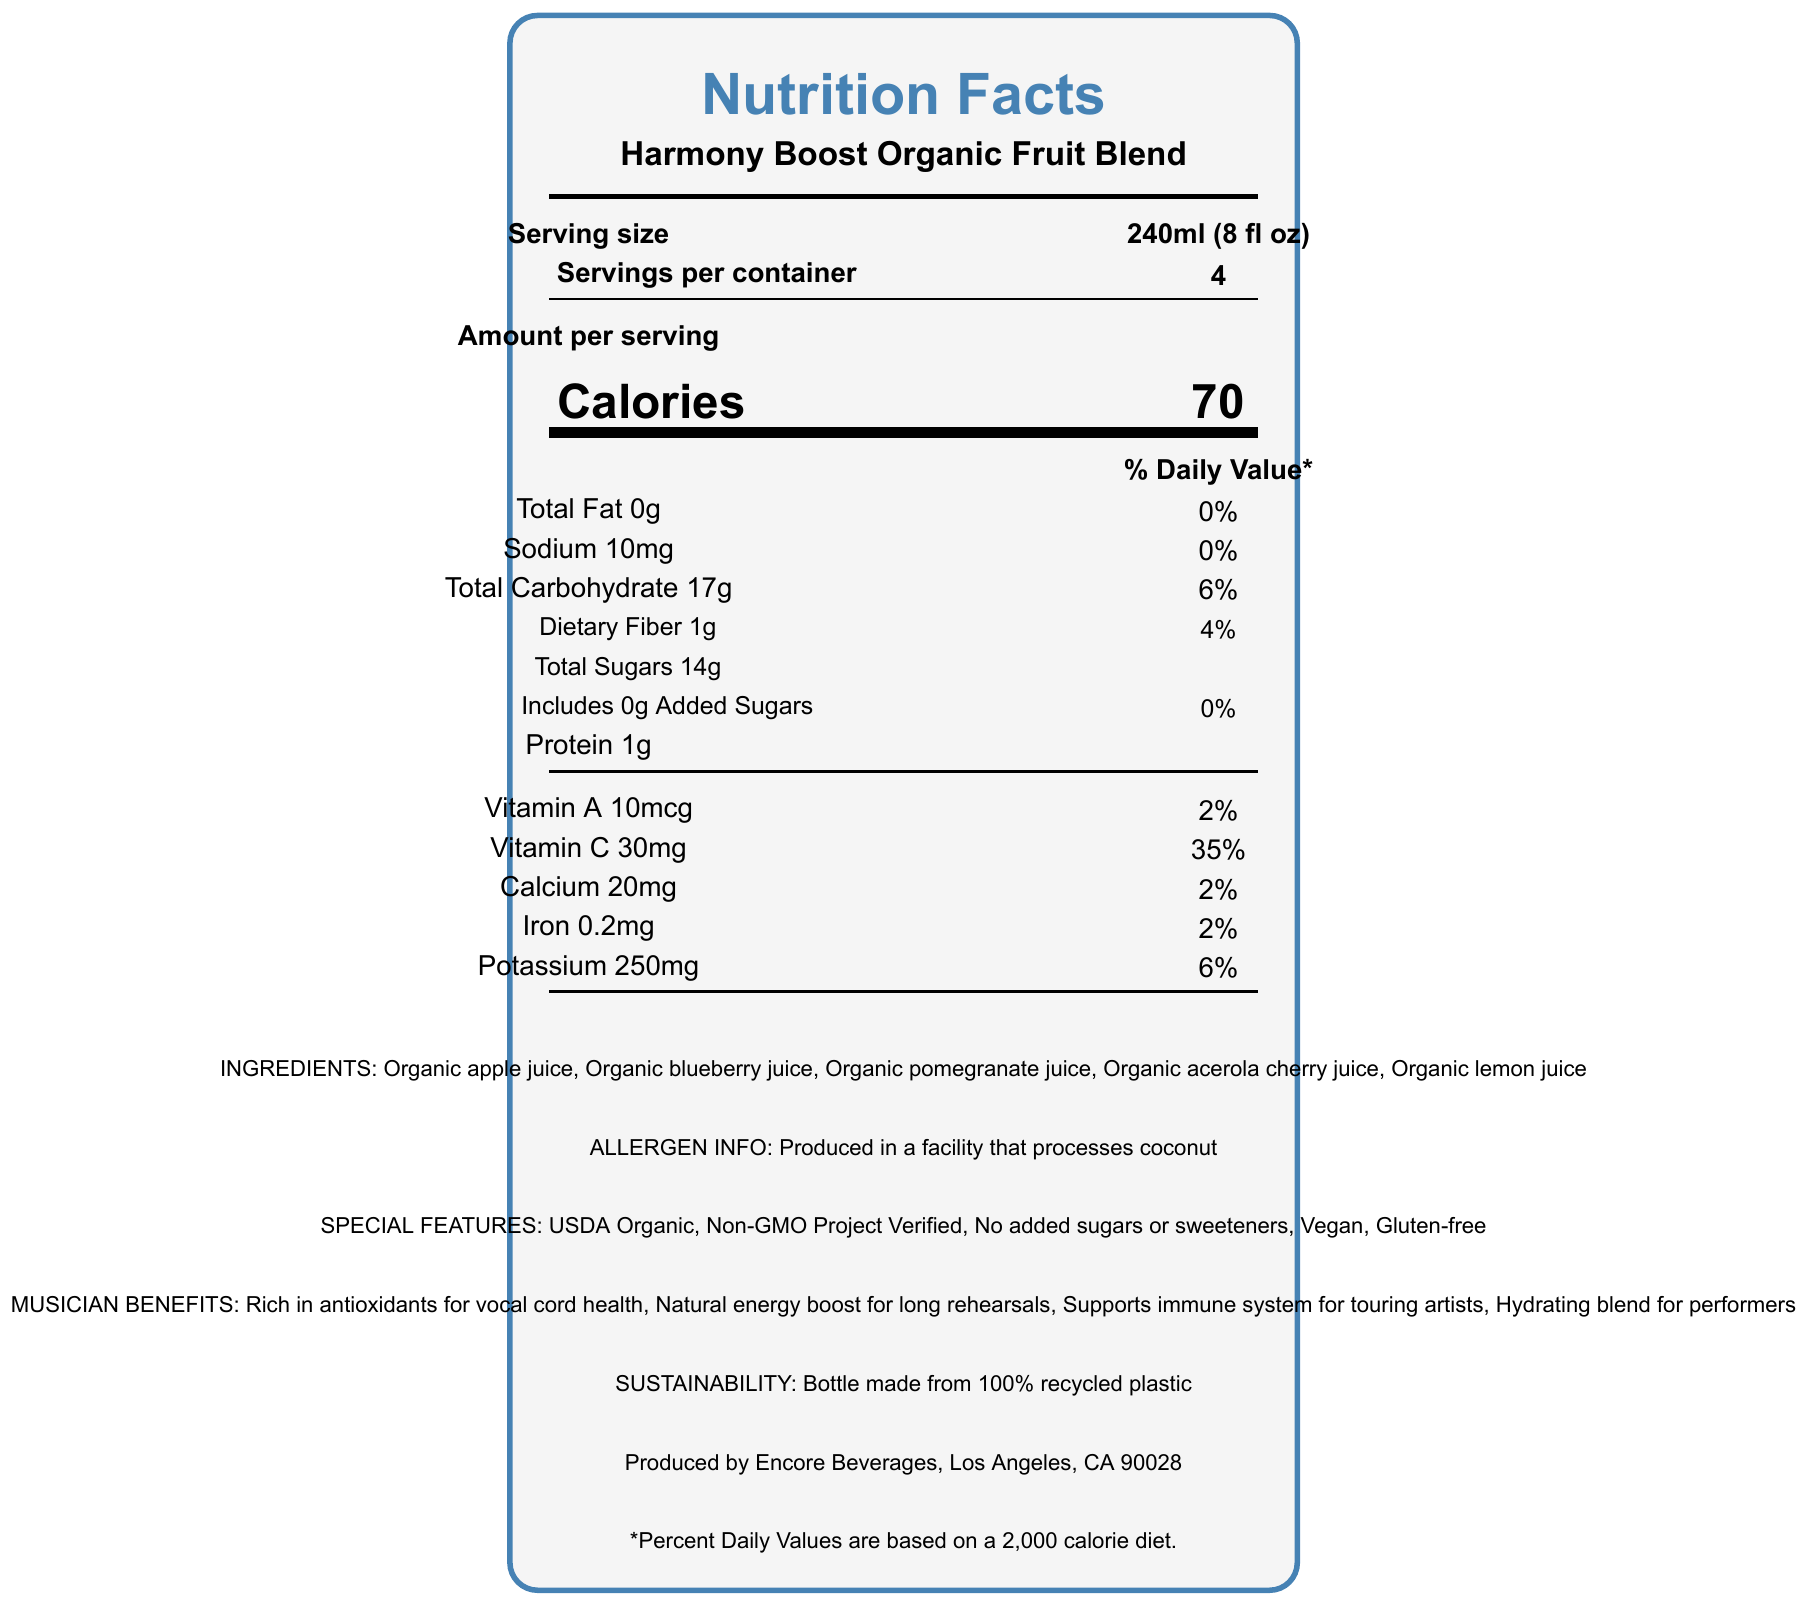what is the serving size of Harmony Boost Organic Fruit Blend? The document specifies the serving size as 240ml (8 fl oz).
Answer: 240ml (8 fl oz) how many servings are there per container? The document states there are 4 servings per container.
Answer: 4 how many calories are there per serving in this fruit blend? The document indicates that each serving has 70 calories.
Answer: 70 what percentage of daily value does 10mg of sodium represent? According to the document, 10mg of sodium corresponds to 0% of the daily value.
Answer: 0% how much dietary fiber is in each serving? The document lists the dietary fiber content per serving as 1g.
Answer: 1g how much vitamin C does one serving provide? A. 10% B. 35% C. 50% The document specifically states that one serving provides 35% of the daily value for vitamin C.
Answer: B which of the following ingredients is NOT listed in the fruit blend? 1. Organic apple juice 2. Organic blueberry juice 3. Organic orange juice 4. Organic lemon juice The document lists ingredients as organic apple juice, organic blueberry juice, organic pomegranate juice, organic acerola cherry juice, and organic lemon juice, but not organic orange juice.
Answer: 3. Organic orange juice is this product gluten-free? The special features section of the document indicates that the product is gluten-free.
Answer: Yes summarize the main idea of the document. The label provides comprehensive information on the nutritional values such as calories, fats, sodium, carbohydrates, proteins, vitamins, and minerals. It also details the ingredients, special features like being organic and gluten-free, the benefits for musicians, and sustainability aspects.
Answer: The document is a nutrition facts label for Harmony Boost Organic Fruit Blend, outlining serving sizes, nutritional content per serving, ingredients, special features, potential musician benefits, sustainability info, and manufacturer details. how much protein is in the entire container? Explanation: There is 1g of protein per serving, and with 4 servings per container, the total protein is 1g * 4 = 4g.
Answer: 4g what are some of the special features of the Harmony Boost Organic Fruit Blend? The document lists special features including USDA Organic, Non-GMO Project Verified, No added sugars or sweeteners, Vegan, and Gluten-free.
Answer: USDA Organic, Non-GMO Project Verified, No added sugars or sweeteners, Vegan, Gluten-free how is the bottle of Harmony Boost Organic Fruit Blend environmentally friendly? The sustainability information provided in the document states that the bottle is made from 100% recycled plastic.
Answer: Bottle made from 100% recycled plastic what benefits does this beverage provide specifically for musicians? The musician benefits section of the document highlights these specific advantages.
Answer: Rich in antioxidants for vocal cord health, Natural energy boost for long rehearsals, Supports immune system for touring artists, Hydrating blend for performers which vitamins does this fruit blend contain? The document lists both Vitamin A (10mcg) and Vitamin C (30mg) as part of its nutritional content.
Answer: Vitamin A and Vitamin C can you describe what the serving size and servings per container are? The document specifies that each serving size is 240ml (8 fl oz) and there are 4 servings in each container.
Answer: Serving size is 240ml (8 fl oz) and servings per container is 4. is this product suitable for someone allergic to coconut? The allergen info section indicates that the product is produced in a facility that processes coconut, which might be a concern for someone with a coconut allergy.
Answer: Possibly not what is the daily value percentage for iron in this fruit blend? According to the nutritional information, each serving of the fruit blend provides 2% of the daily value for iron.
Answer: 2% what is the brand of this fruit blend? The document states the brand of the fruit blend as Backstage Nutrition.
Answer: Backstage Nutrition what are the main ingredients in this fruit blend? The ingredients list provided in the document specifies these as the main components.
Answer: Organic apple juice, Organic blueberry juice, Organic pomegranate juice, Organic acerola cherry juice, Organic lemon juice who is the manufacturer of this product? The document mentions that the product is produced by Encore Beverages, Los Angeles, CA 90028.
Answer: Encore Beverages, Los Angeles, CA 90028 how many grams of added sugars are in each serving? The document states that each serving includes 0g of added sugars.
Answer: 0g how does this fruit blend support the immune system? The musician benefits section highlights that this fruit blend supports the immune system, partly due to its Vitamin C and antioxidant content.
Answer: By containing Vitamin C and antioxidants does the document provide information on the total weight of the container? The document does not mention the total weight of the container, only the serving size and the number of servings per container.
Answer: Not enough information 